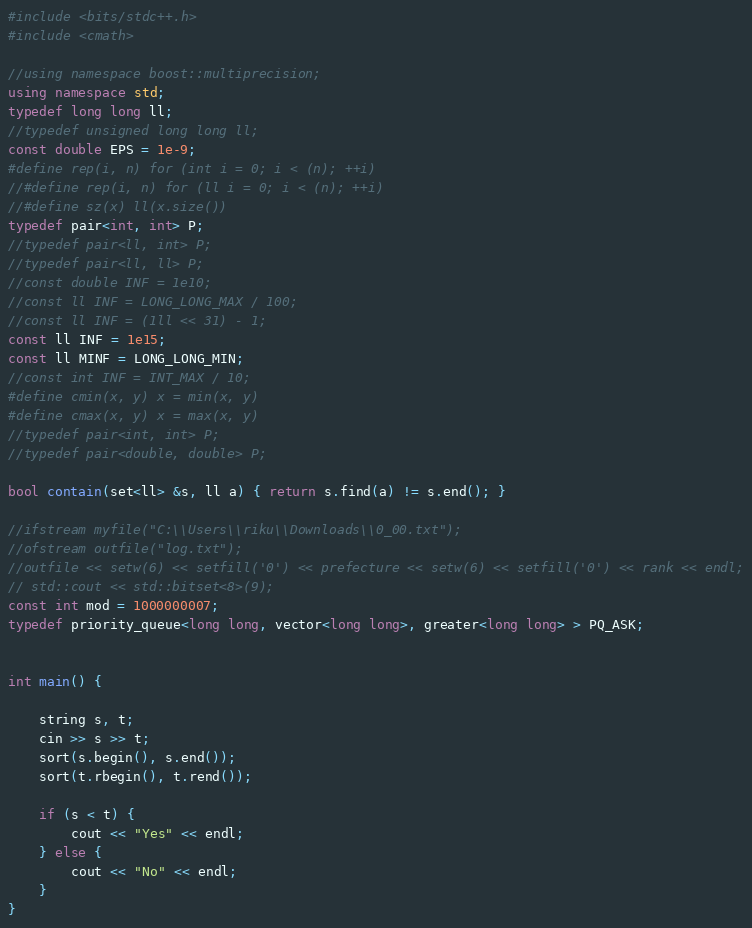<code> <loc_0><loc_0><loc_500><loc_500><_C++_>#include <bits/stdc++.h>
#include <cmath>

//using namespace boost::multiprecision;
using namespace std;
typedef long long ll;
//typedef unsigned long long ll;
const double EPS = 1e-9;
#define rep(i, n) for (int i = 0; i < (n); ++i)
//#define rep(i, n) for (ll i = 0; i < (n); ++i)
//#define sz(x) ll(x.size())
typedef pair<int, int> P;
//typedef pair<ll, int> P;
//typedef pair<ll, ll> P;
//const double INF = 1e10;
//const ll INF = LONG_LONG_MAX / 100;
//const ll INF = (1ll << 31) - 1;
const ll INF = 1e15;
const ll MINF = LONG_LONG_MIN;
//const int INF = INT_MAX / 10;
#define cmin(x, y) x = min(x, y)
#define cmax(x, y) x = max(x, y)
//typedef pair<int, int> P;
//typedef pair<double, double> P;

bool contain(set<ll> &s, ll a) { return s.find(a) != s.end(); }

//ifstream myfile("C:\\Users\\riku\\Downloads\\0_00.txt");
//ofstream outfile("log.txt");
//outfile << setw(6) << setfill('0') << prefecture << setw(6) << setfill('0') << rank << endl;
// std::cout << std::bitset<8>(9);
const int mod = 1000000007;
typedef priority_queue<long long, vector<long long>, greater<long long> > PQ_ASK;


int main() {

    string s, t;
    cin >> s >> t;
    sort(s.begin(), s.end());
    sort(t.rbegin(), t.rend());

    if (s < t) {
        cout << "Yes" << endl;
    } else {
        cout << "No" << endl;
    }
}

</code> 